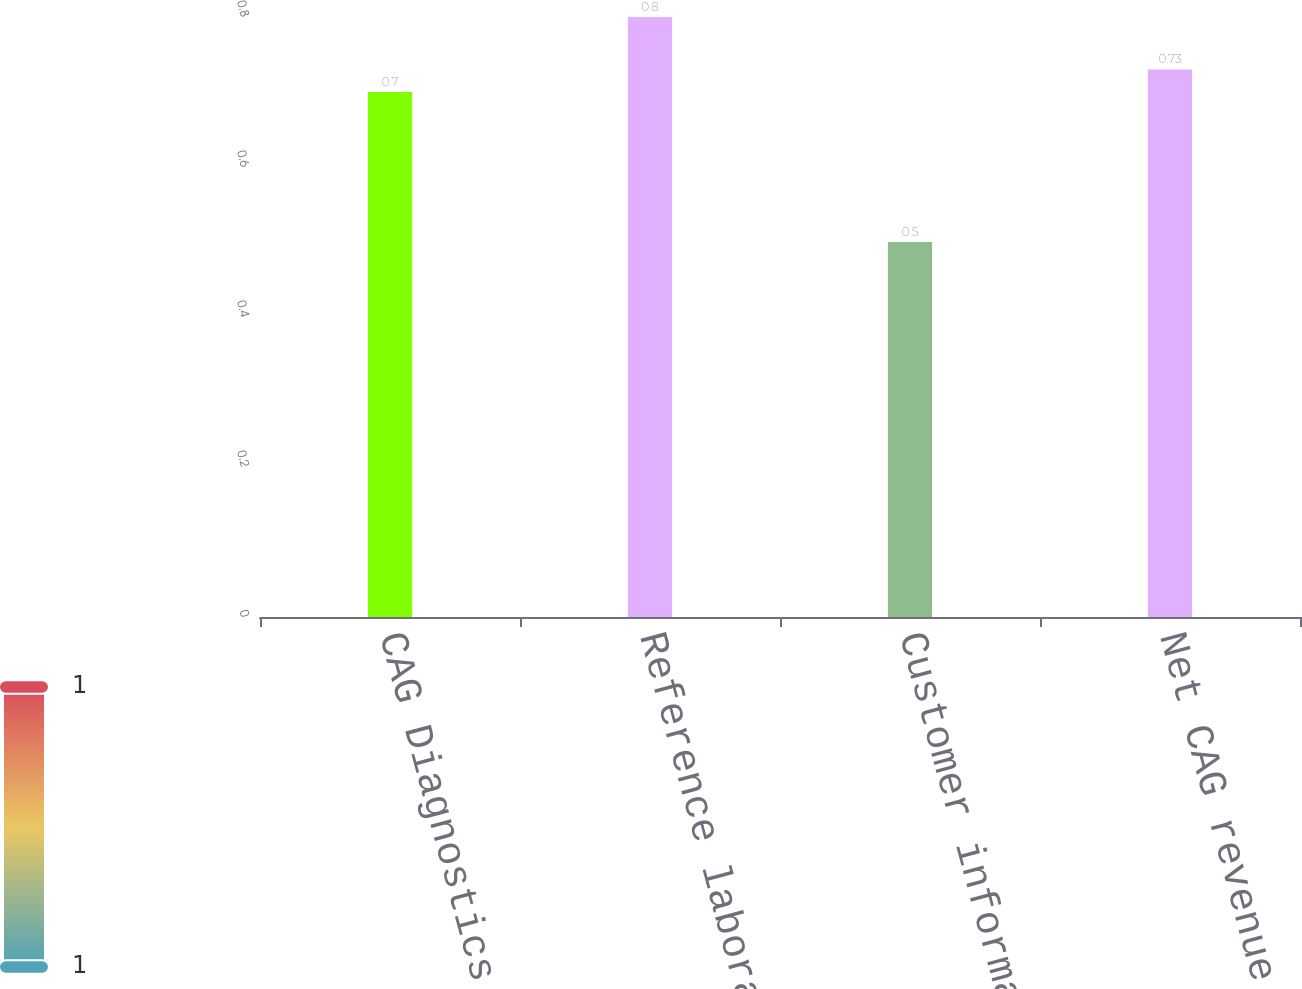Convert chart. <chart><loc_0><loc_0><loc_500><loc_500><bar_chart><fcel>CAG Diagnostics recurring<fcel>Reference laboratory<fcel>Customer information<fcel>Net CAG revenue<nl><fcel>0.7<fcel>0.8<fcel>0.5<fcel>0.73<nl></chart> 